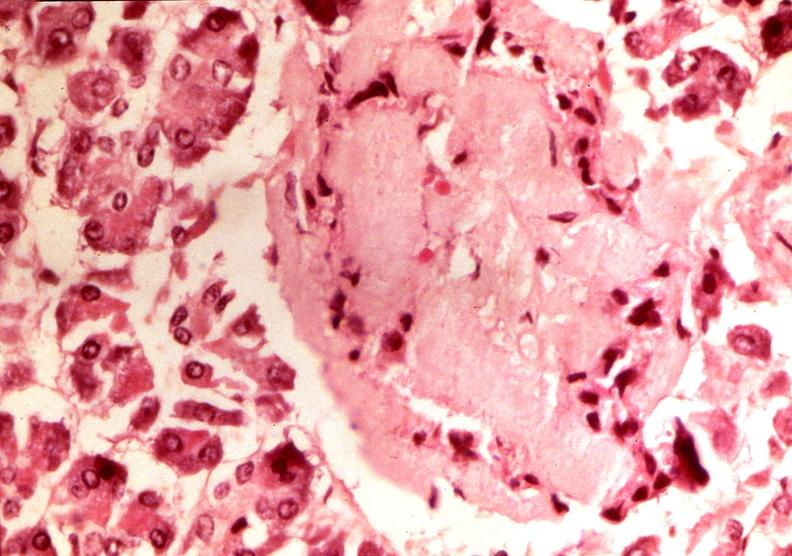does this image show pancrease, islet amyloid, diabetes mellitus?
Answer the question using a single word or phrase. Yes 